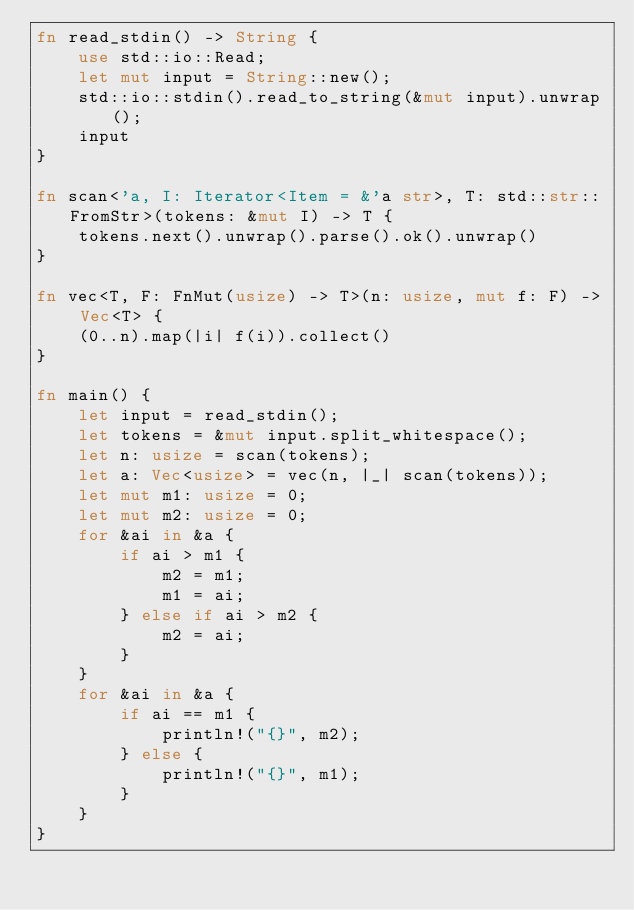<code> <loc_0><loc_0><loc_500><loc_500><_Rust_>fn read_stdin() -> String {
    use std::io::Read;
    let mut input = String::new();
    std::io::stdin().read_to_string(&mut input).unwrap();
    input
}

fn scan<'a, I: Iterator<Item = &'a str>, T: std::str::FromStr>(tokens: &mut I) -> T {
    tokens.next().unwrap().parse().ok().unwrap()
}

fn vec<T, F: FnMut(usize) -> T>(n: usize, mut f: F) -> Vec<T> {
    (0..n).map(|i| f(i)).collect()
}

fn main() {
    let input = read_stdin();
    let tokens = &mut input.split_whitespace();
    let n: usize = scan(tokens);
    let a: Vec<usize> = vec(n, |_| scan(tokens));
    let mut m1: usize = 0;
    let mut m2: usize = 0;
    for &ai in &a {
        if ai > m1 {
            m2 = m1;
            m1 = ai;
        } else if ai > m2 {
            m2 = ai;
        }
    }
    for &ai in &a {
        if ai == m1 {
            println!("{}", m2);
        } else {
            println!("{}", m1);
        }
    }
}
</code> 